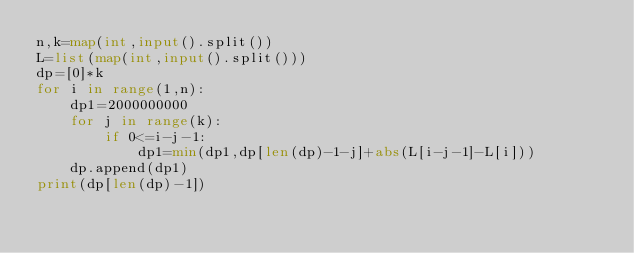<code> <loc_0><loc_0><loc_500><loc_500><_Python_>n,k=map(int,input().split())
L=list(map(int,input().split()))
dp=[0]*k
for i in range(1,n):
    dp1=2000000000
    for j in range(k):
        if 0<=i-j-1:
            dp1=min(dp1,dp[len(dp)-1-j]+abs(L[i-j-1]-L[i]))
    dp.append(dp1)
print(dp[len(dp)-1])
</code> 